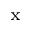Convert formula to latex. <formula><loc_0><loc_0><loc_500><loc_500>_ { x }</formula> 